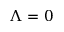Convert formula to latex. <formula><loc_0><loc_0><loc_500><loc_500>\Lambda = 0</formula> 